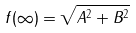<formula> <loc_0><loc_0><loc_500><loc_500>f ( \infty ) = \sqrt { A ^ { 2 } + B ^ { 2 } }</formula> 